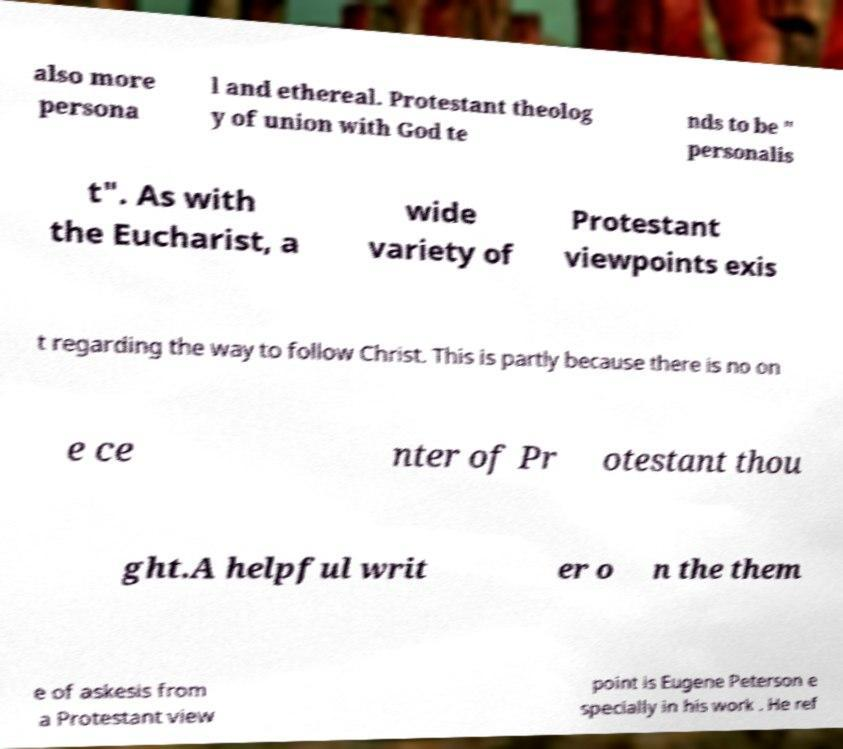Could you assist in decoding the text presented in this image and type it out clearly? also more persona l and ethereal. Protestant theolog y of union with God te nds to be " personalis t". As with the Eucharist, a wide variety of Protestant viewpoints exis t regarding the way to follow Christ. This is partly because there is no on e ce nter of Pr otestant thou ght.A helpful writ er o n the them e of askesis from a Protestant view point is Eugene Peterson e specially in his work . He ref 